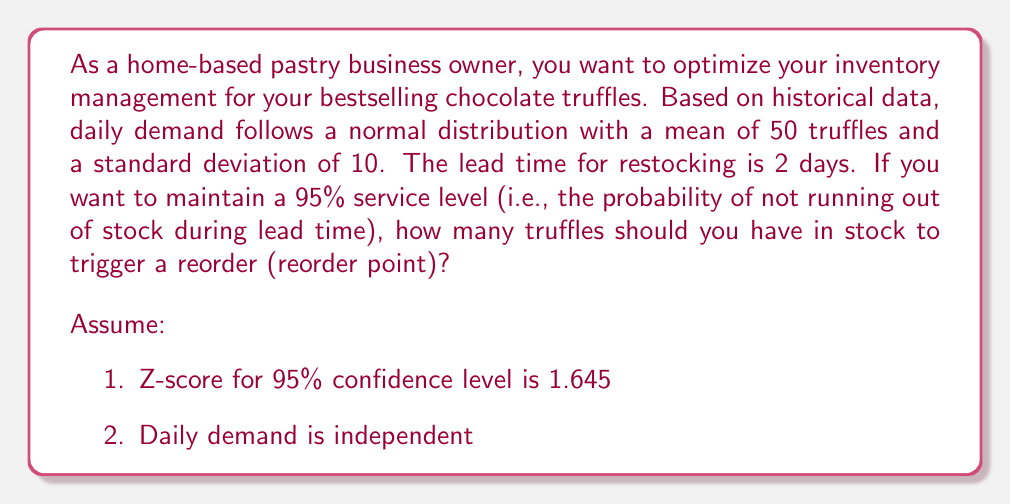Show me your answer to this math problem. To solve this problem, we need to calculate the reorder point using the following steps:

1. Calculate the mean demand during lead time:
   $$\mu_{LT} = \text{Daily mean} \times \text{Lead time}$$
   $$\mu_{LT} = 50 \times 2 = 100 \text{ truffles}$$

2. Calculate the standard deviation during lead time:
   $$\sigma_{LT} = \sigma_{daily} \times \sqrt{\text{Lead time}}$$
   $$\sigma_{LT} = 10 \times \sqrt{2} \approx 14.14 \text{ truffles}$$

3. Calculate the safety stock using the Z-score for 95% service level:
   $$\text{Safety Stock} = Z \times \sigma_{LT}$$
   $$\text{Safety Stock} = 1.645 \times 14.14 \approx 23.26 \text{ truffles}$$

4. Calculate the reorder point:
   $$\text{Reorder Point} = \mu_{LT} + \text{Safety Stock}$$
   $$\text{Reorder Point} = 100 + 23.26 \approx 123.26 \text{ truffles}$$

5. Round up to the nearest whole number, as we can't order fractional truffles:
   $$\text{Reorder Point} = 124 \text{ truffles}$$

Therefore, you should place a new order when your inventory reaches 124 truffles to maintain a 95% service level.
Answer: 124 truffles 